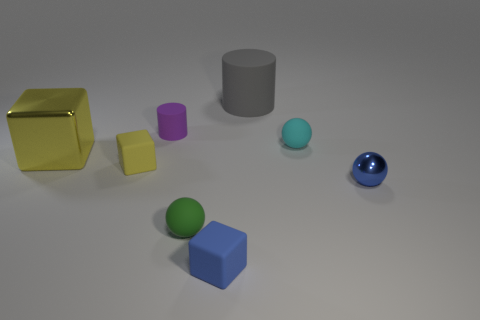Subtract all small rubber spheres. How many spheres are left? 1 Subtract all red cylinders. How many yellow blocks are left? 2 Add 1 yellow rubber objects. How many objects exist? 9 Subtract all purple cylinders. How many cylinders are left? 1 Subtract all cubes. How many objects are left? 5 Subtract 1 blocks. How many blocks are left? 2 Subtract 0 cyan cylinders. How many objects are left? 8 Subtract all red blocks. Subtract all purple cylinders. How many blocks are left? 3 Subtract all yellow shiny things. Subtract all small green objects. How many objects are left? 6 Add 4 balls. How many balls are left? 7 